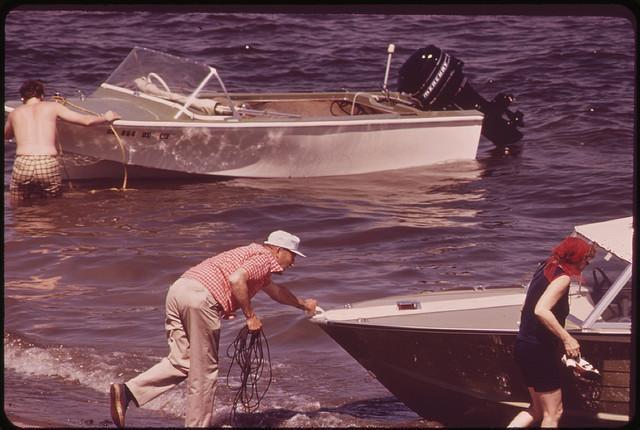How many boats are there?
Give a very brief answer. 2. How many people are there?
Give a very brief answer. 3. How many of the dogs are black?
Give a very brief answer. 0. 